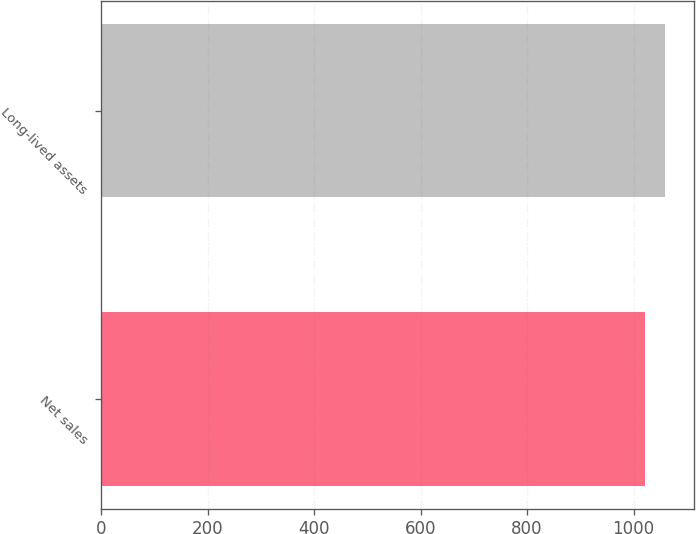Convert chart to OTSL. <chart><loc_0><loc_0><loc_500><loc_500><bar_chart><fcel>Net sales<fcel>Long-lived assets<nl><fcel>1021.1<fcel>1060<nl></chart> 